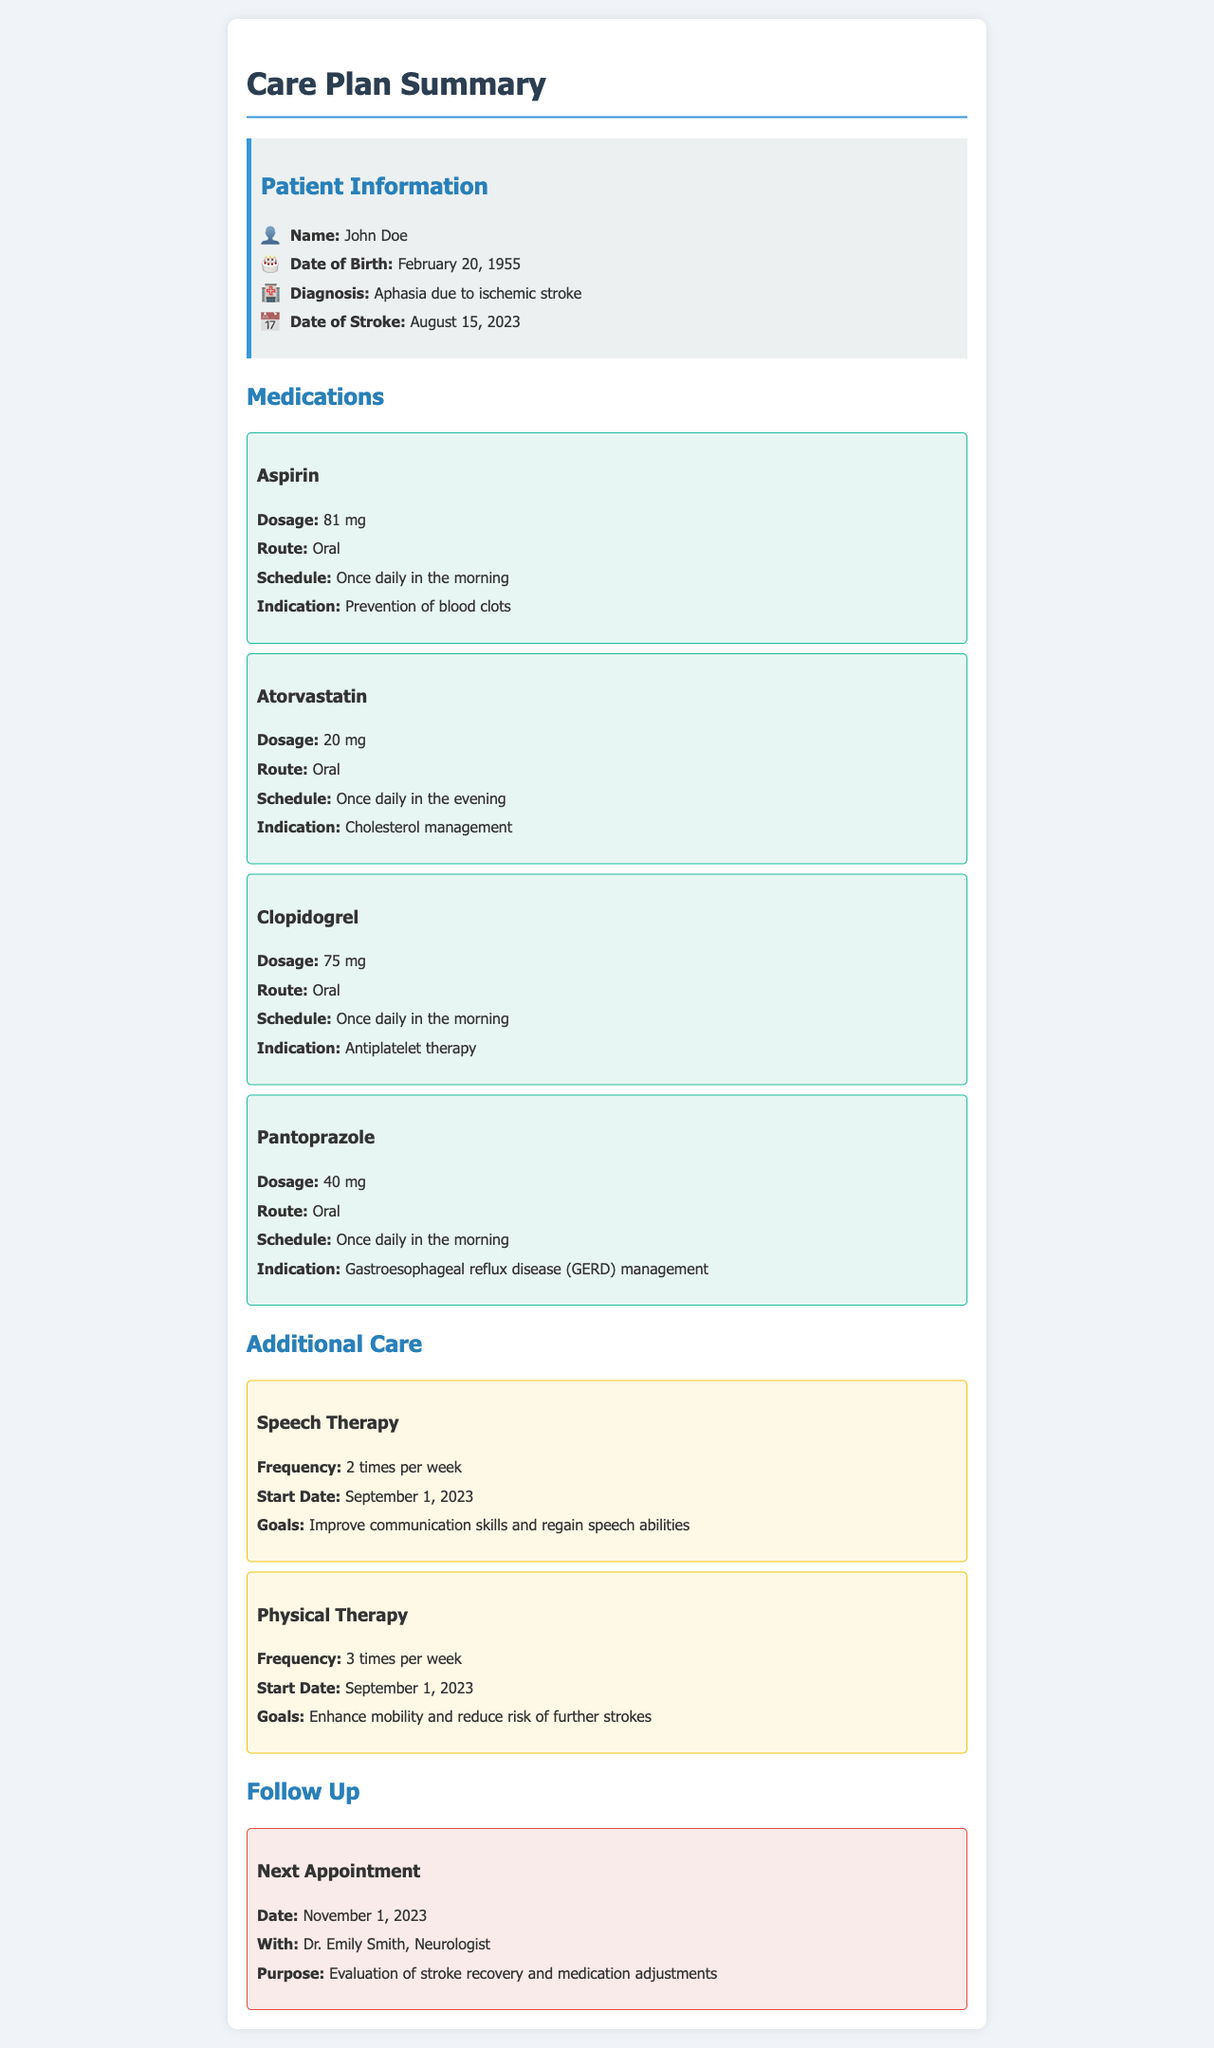What is the patient's name? The name of the patient is provided in the patient information section of the document.
Answer: John Doe What medication is prescribed for cholesterol management? The document lists the medications along with their indications; atorvastatin is for cholesterol management.
Answer: Atorvastatin What is the dosage of Clopidogrel? The specific dosage of each medication is included in the respective medication section.
Answer: 75 mg How often is speech therapy scheduled? The frequency of speech therapy is stated in the additional care section.
Answer: 2 times per week When is the next appointment scheduled? The next appointment date is mentioned in the follow-up section.
Answer: November 1, 2023 What is the main goal of physical therapy? Goals for each type of therapy are outlined in the document, particularly for physical therapy.
Answer: Enhance mobility and reduce risk of further strokes What is the route for taking Aspirin? The document specifies the route of administration for each medication listed.
Answer: Oral What is the indication for Pantoprazole? Each medication's indication is included in the document; pantoprazole is for managing a specific condition.
Answer: Gastroesophageal reflux disease (GERD) management Who will the patient see during the next appointment? The follow-up section mentions the healthcare provider and purpose of the appointment.
Answer: Dr. Emily Smith, Neurologist 